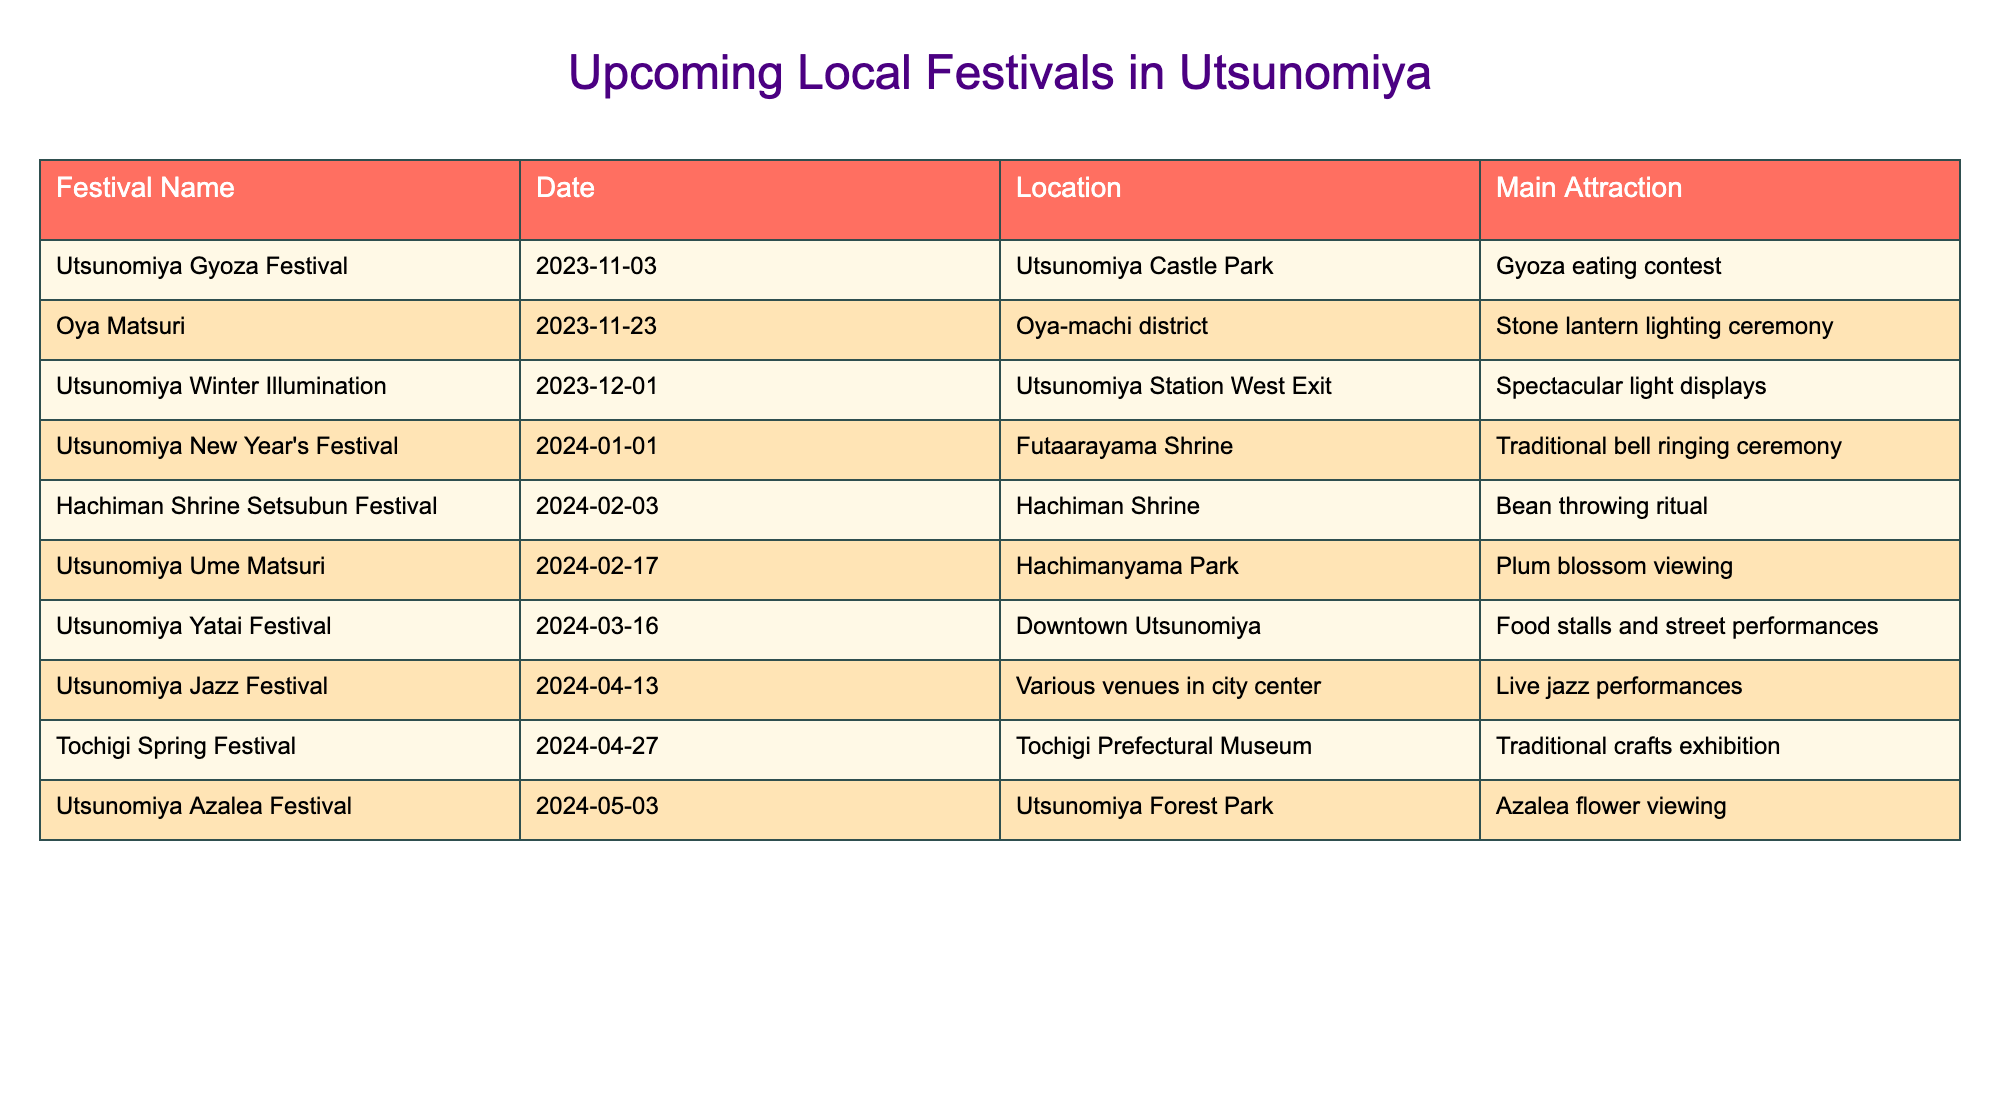What is the date of the Utsunomiya Gyoza Festival? The table lists the Utsunomiya Gyoza Festival with the date mentioned directly next to it, which is November 3, 2023.
Answer: November 3, 2023 How many festivals are scheduled for February 2024? The table shows that there are two festivals in February: Hachiman Shrine Setsubun Festival on February 3 and Utsunomiya Ume Matsuri on February 17. Therefore, the count is 2.
Answer: 2 Which festival features a food-related activity? The table indicates that the Utsunomiya Gyoza Festival has a Gyoza eating contest, making it the festival that features a food-related activity.
Answer: Utsunomiya Gyoza Festival What is the main attraction of the Utsunomiya Winter Illumination? The table shows that the main attraction for the Utsunomiya Winter Illumination is specified as spectacular light displays, found right next to the festival's title and date.
Answer: Spectacular light displays Which festival has the earliest date? Upon reviewing the table, the Utsunomiya Gyoza Festival on November 3, 2023, is the earliest date listed in the upcoming festivals over the next six months.
Answer: Utsunomiya Gyoza Festival In which location is the Tochigi Spring Festival held? The table directly lists the location for the Tochigi Spring Festival as Tochigi Prefectural Museum following its name and date.
Answer: Tochigi Prefectural Museum How many different locations host festivals in Utsunomiya over the next six months? By inspecting the locations listed in the table, we see: Utsunomiya Castle Park, Oya-machi district, Utsunomiya Station West Exit, Futaarayama Shrine, Hachiman Shrine, Hachimanyama Park, Downtown Utsunomiya, Various venues, and Utsunomiya Forest Park. This counts to 9 unique locations.
Answer: 9 Is there a festival featuring traditional crafts? The table shows that the Tochigi Spring Festival includes a traditional crafts exhibition as its main attraction, confirming that such a festival exists.
Answer: Yes Which festival takes place in March 2024? The Utsunomiya Yatai Festival is listed in the table as taking place on March 16, 2024, confirming that this month has a scheduled festival.
Answer: Utsunomiya Yatai Festival If I want to attend a festival with a bean throwing ritual, which one should I go to? The table specifically notes that the Hachiman Shrine Setsubun Festival includes a bean throwing ritual, making this the festival to attend if looking for that activity.
Answer: Hachiman Shrine Setsubun Festival 